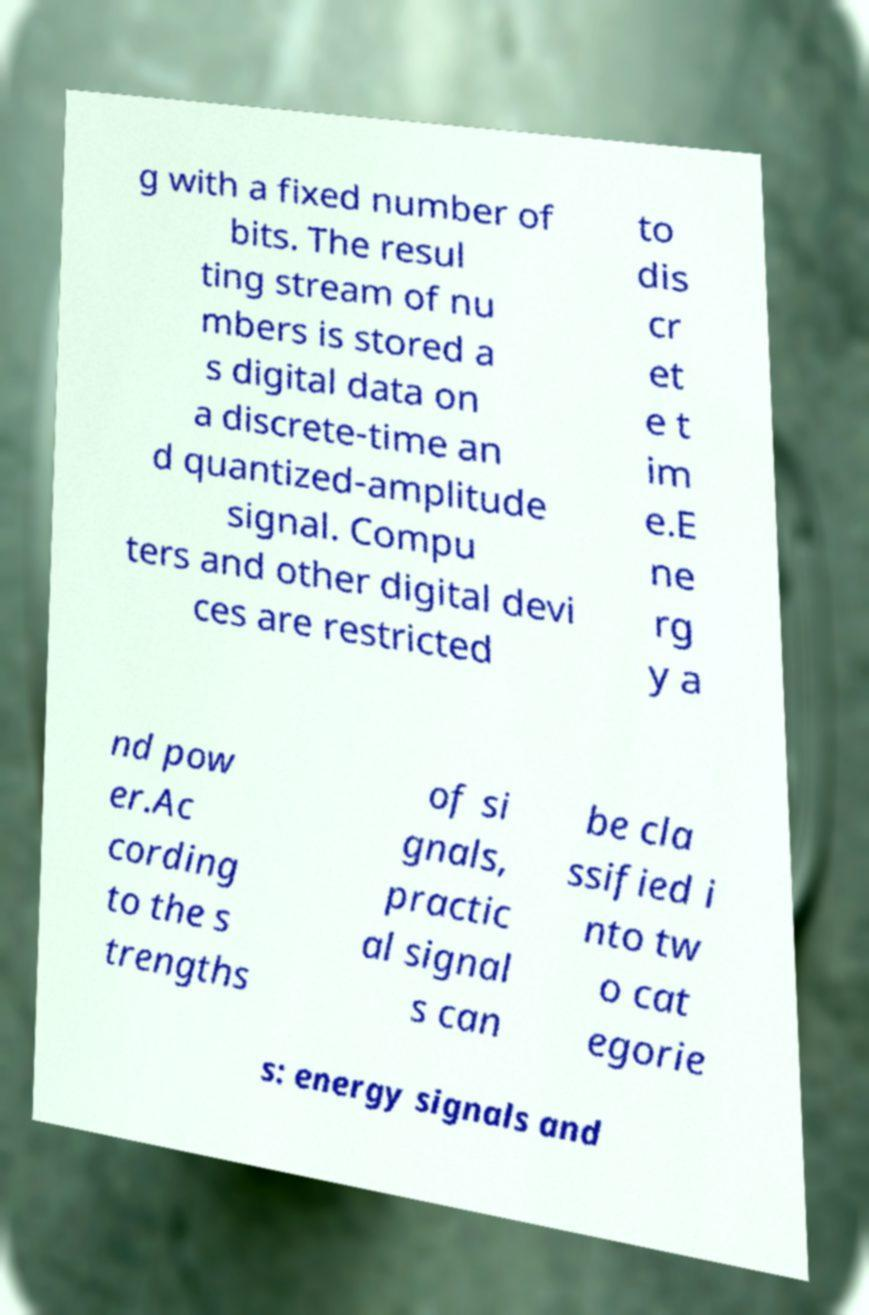What messages or text are displayed in this image? I need them in a readable, typed format. g with a fixed number of bits. The resul ting stream of nu mbers is stored a s digital data on a discrete-time an d quantized-amplitude signal. Compu ters and other digital devi ces are restricted to dis cr et e t im e.E ne rg y a nd pow er.Ac cording to the s trengths of si gnals, practic al signal s can be cla ssified i nto tw o cat egorie s: energy signals and 